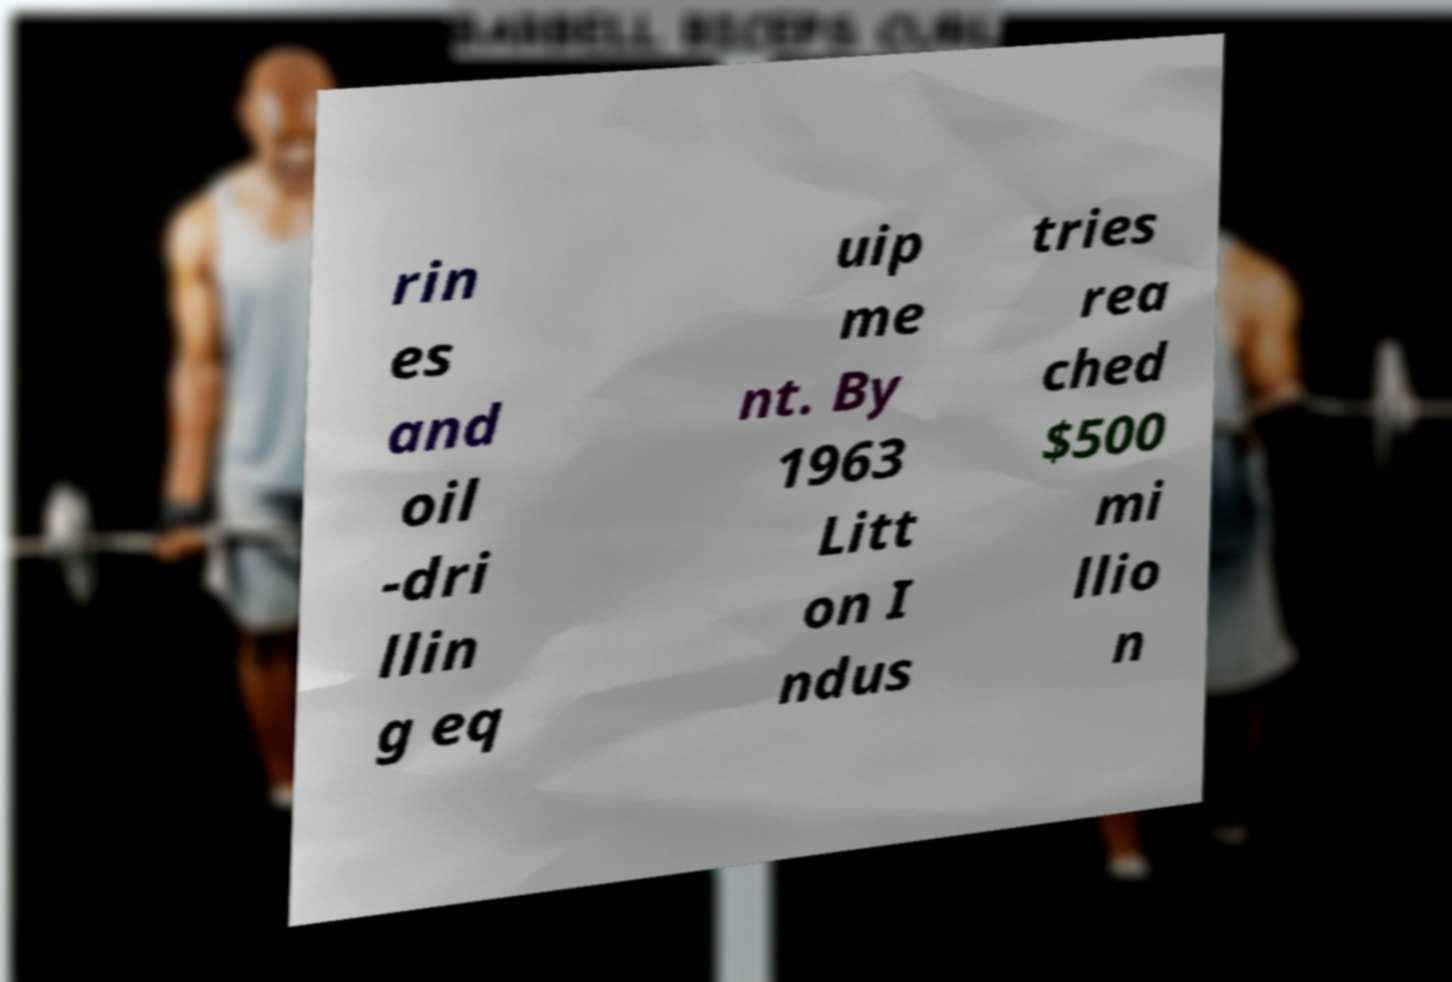Please read and relay the text visible in this image. What does it say? rin es and oil -dri llin g eq uip me nt. By 1963 Litt on I ndus tries rea ched $500 mi llio n 